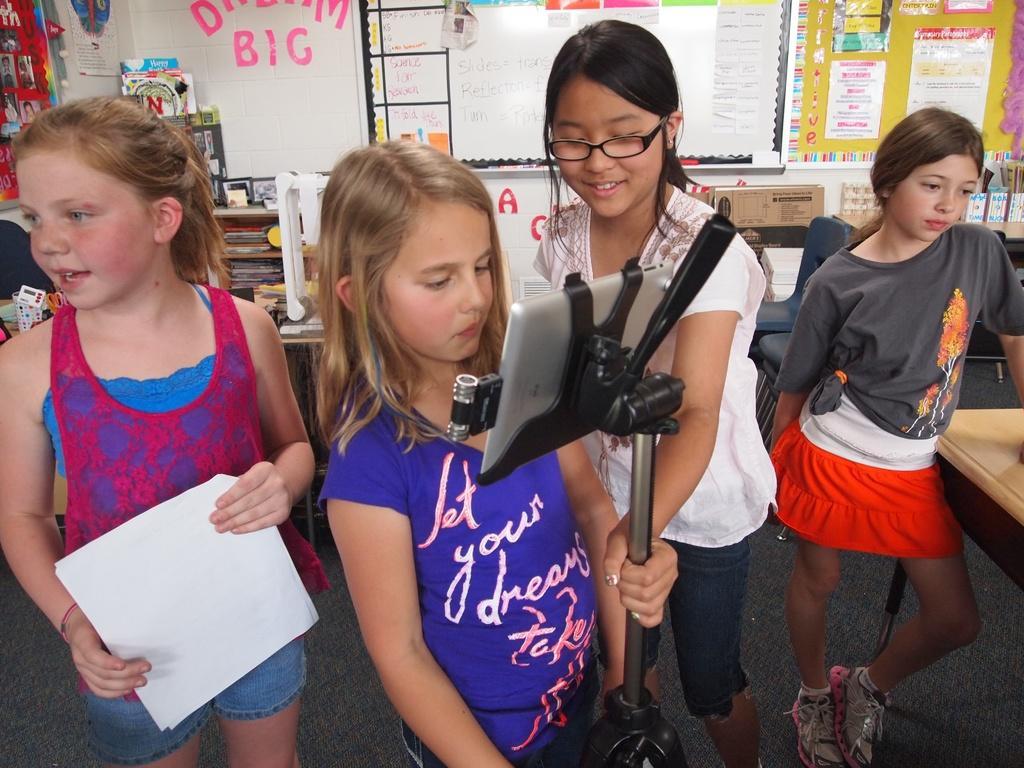Could you give a brief overview of what you see in this image? This is an inside view. Here I can see four girls standing on the floor. The two girls who are in the middle they are holding a metal stand. The girl who is on the left side, she is holding some papers in the hands. On the right side there is a table. In the background there are many objects placed on the tables. At the top of the image there are many posters and a board attached to the wall. 